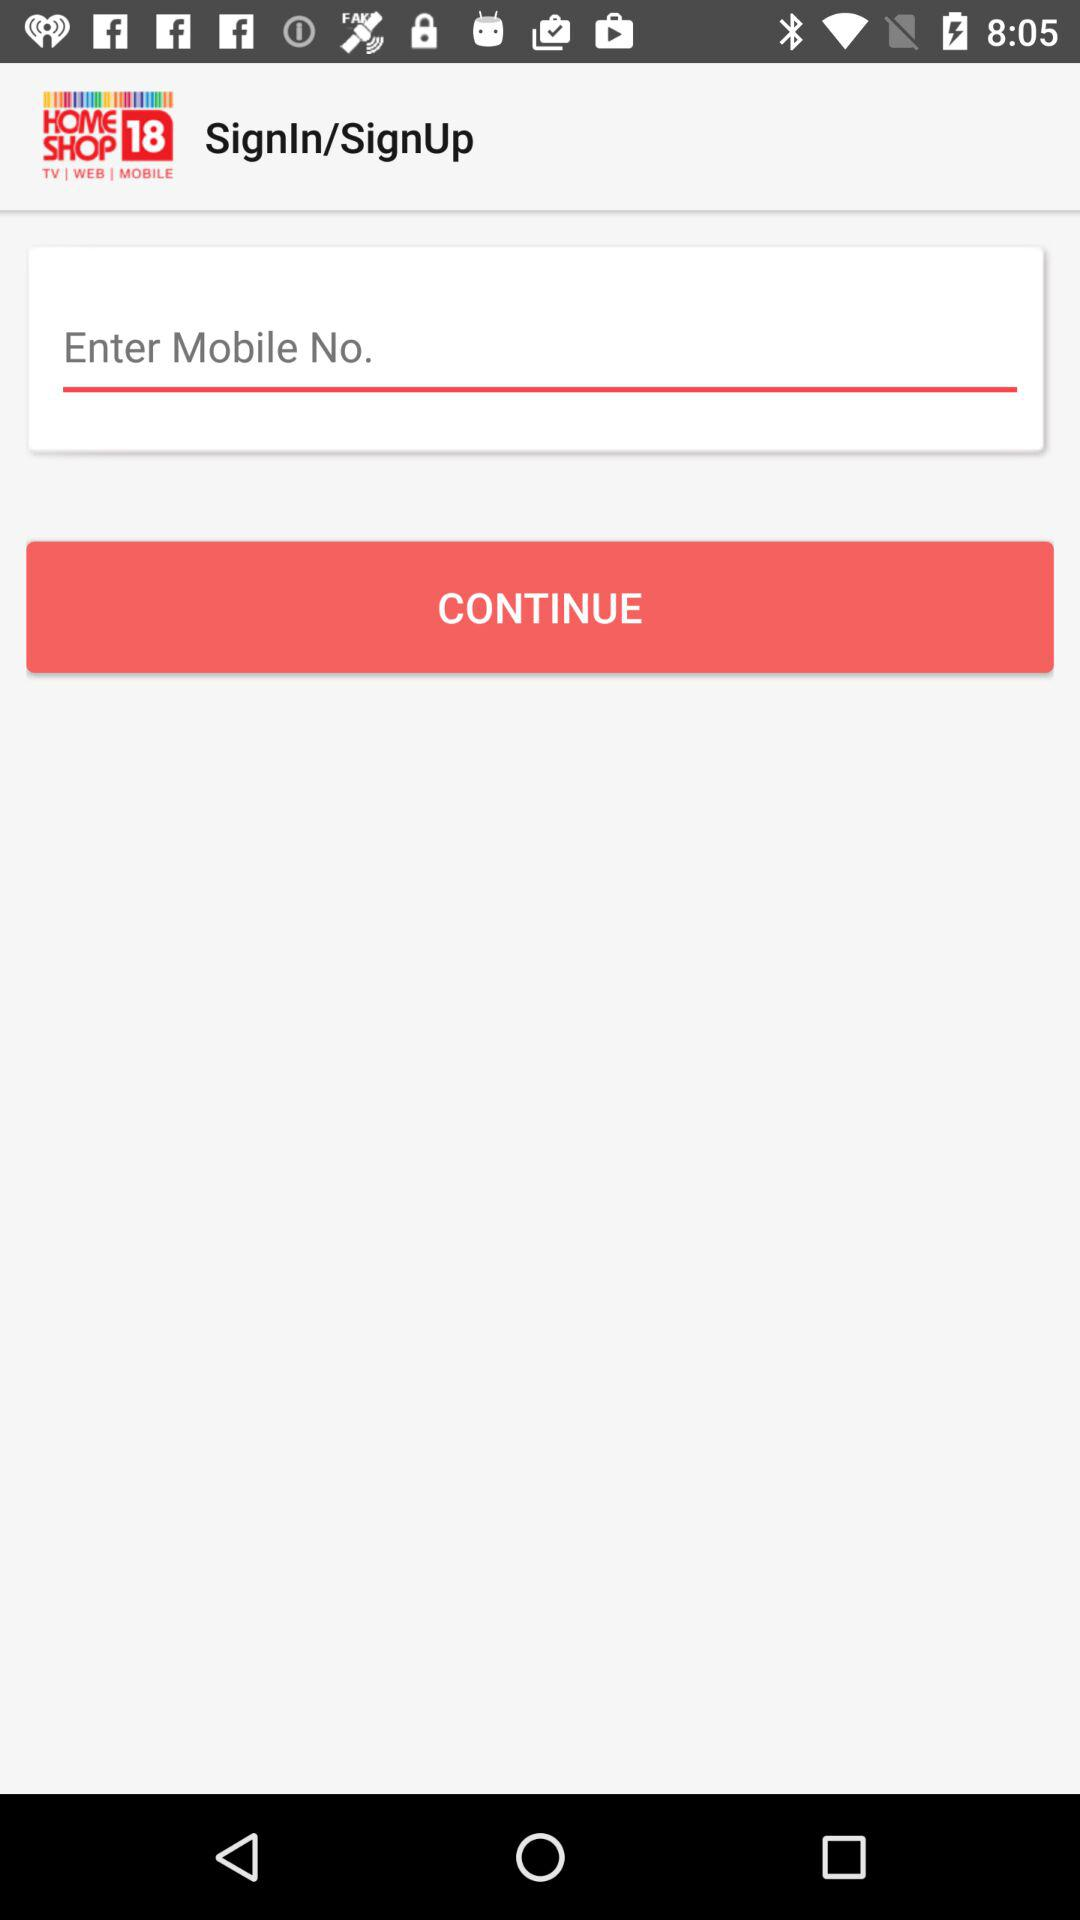What is the application name? The application name is "HOMESHOP 18". 